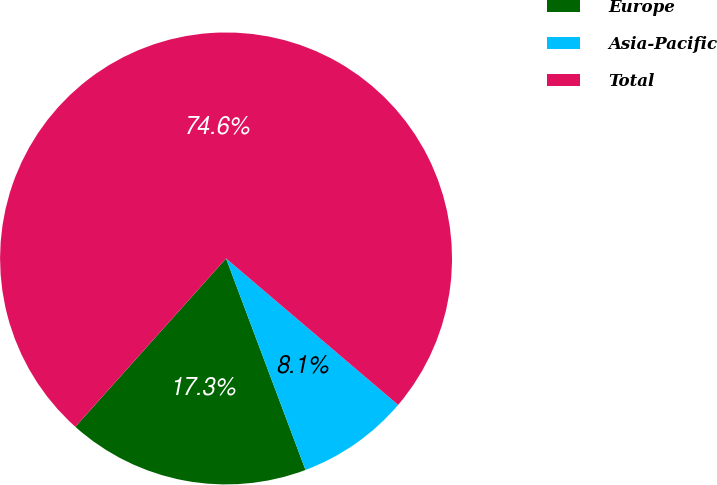Convert chart to OTSL. <chart><loc_0><loc_0><loc_500><loc_500><pie_chart><fcel>Europe<fcel>Asia-Pacific<fcel>Total<nl><fcel>17.34%<fcel>8.06%<fcel>74.6%<nl></chart> 